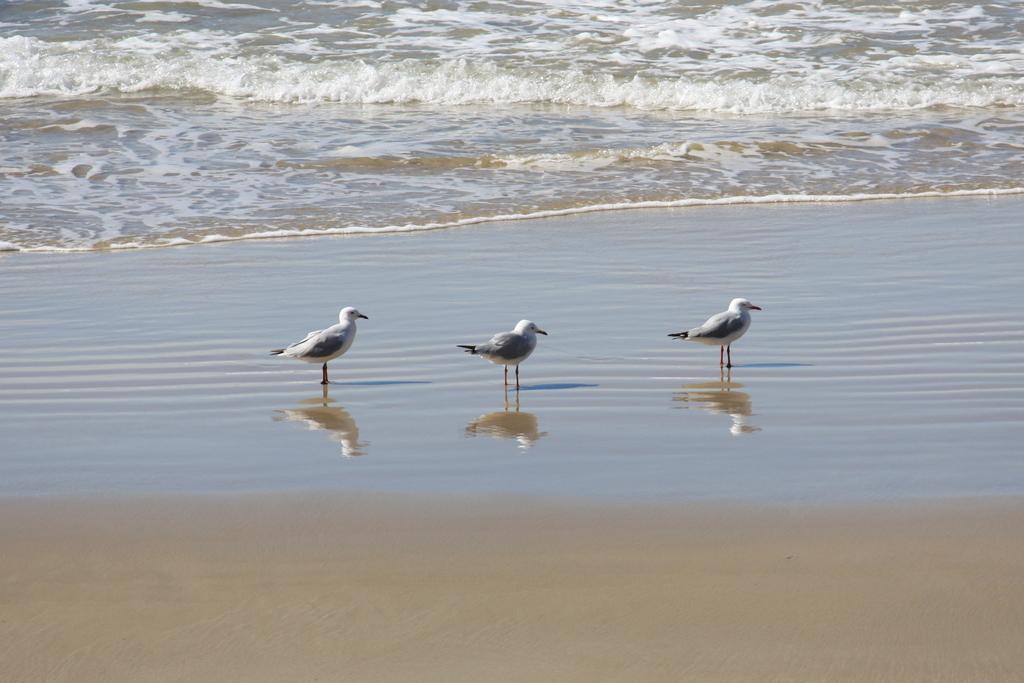Can you describe this image briefly? This is the picture of a sea. In this image there are birds standing. At the back there is water. At the bottom there is sand. There is a reflection of birds on the water. 